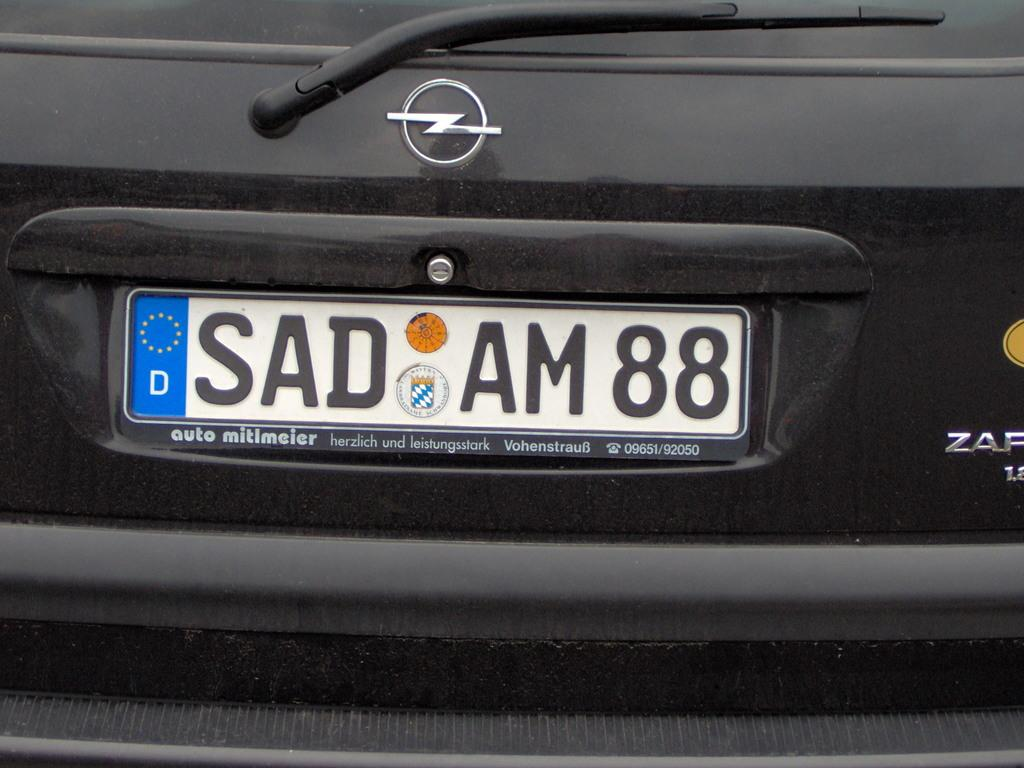<image>
Offer a succinct explanation of the picture presented. The back of a car with license plates that say 'SAD AM 88' 